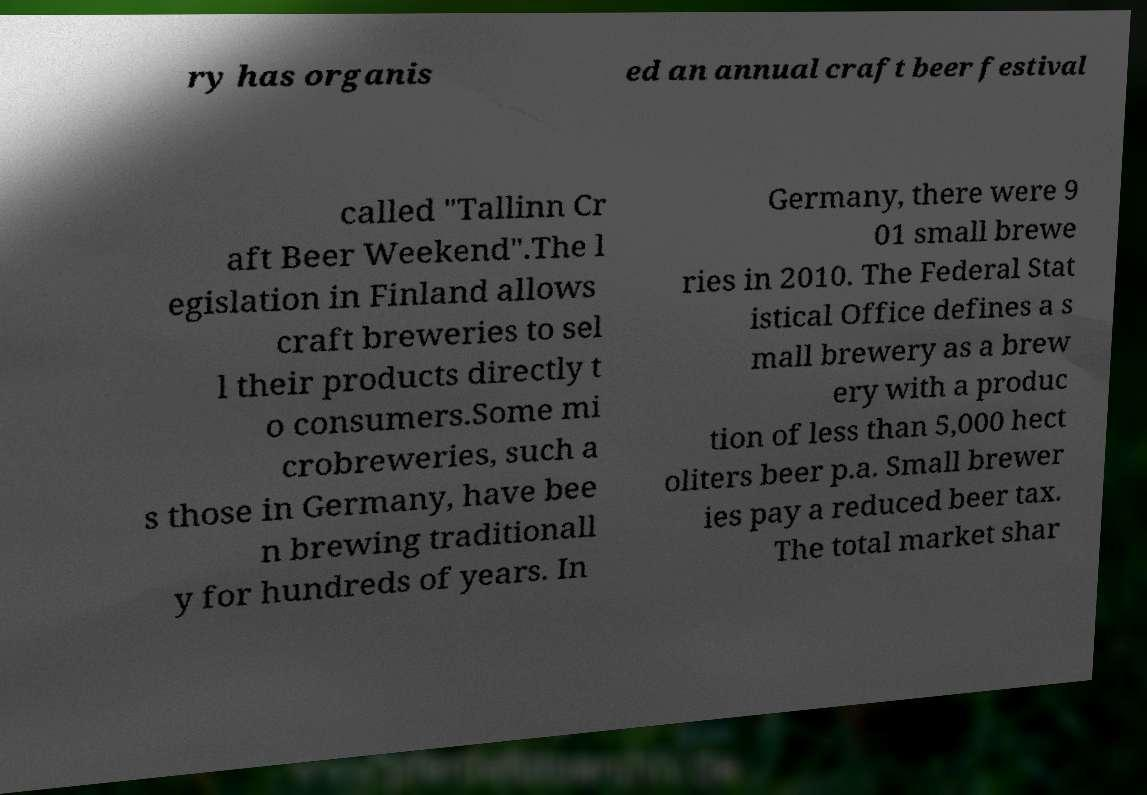Please read and relay the text visible in this image. What does it say? ry has organis ed an annual craft beer festival called "Tallinn Cr aft Beer Weekend".The l egislation in Finland allows craft breweries to sel l their products directly t o consumers.Some mi crobreweries, such a s those in Germany, have bee n brewing traditionall y for hundreds of years. In Germany, there were 9 01 small brewe ries in 2010. The Federal Stat istical Office defines a s mall brewery as a brew ery with a produc tion of less than 5,000 hect oliters beer p.a. Small brewer ies pay a reduced beer tax. The total market shar 